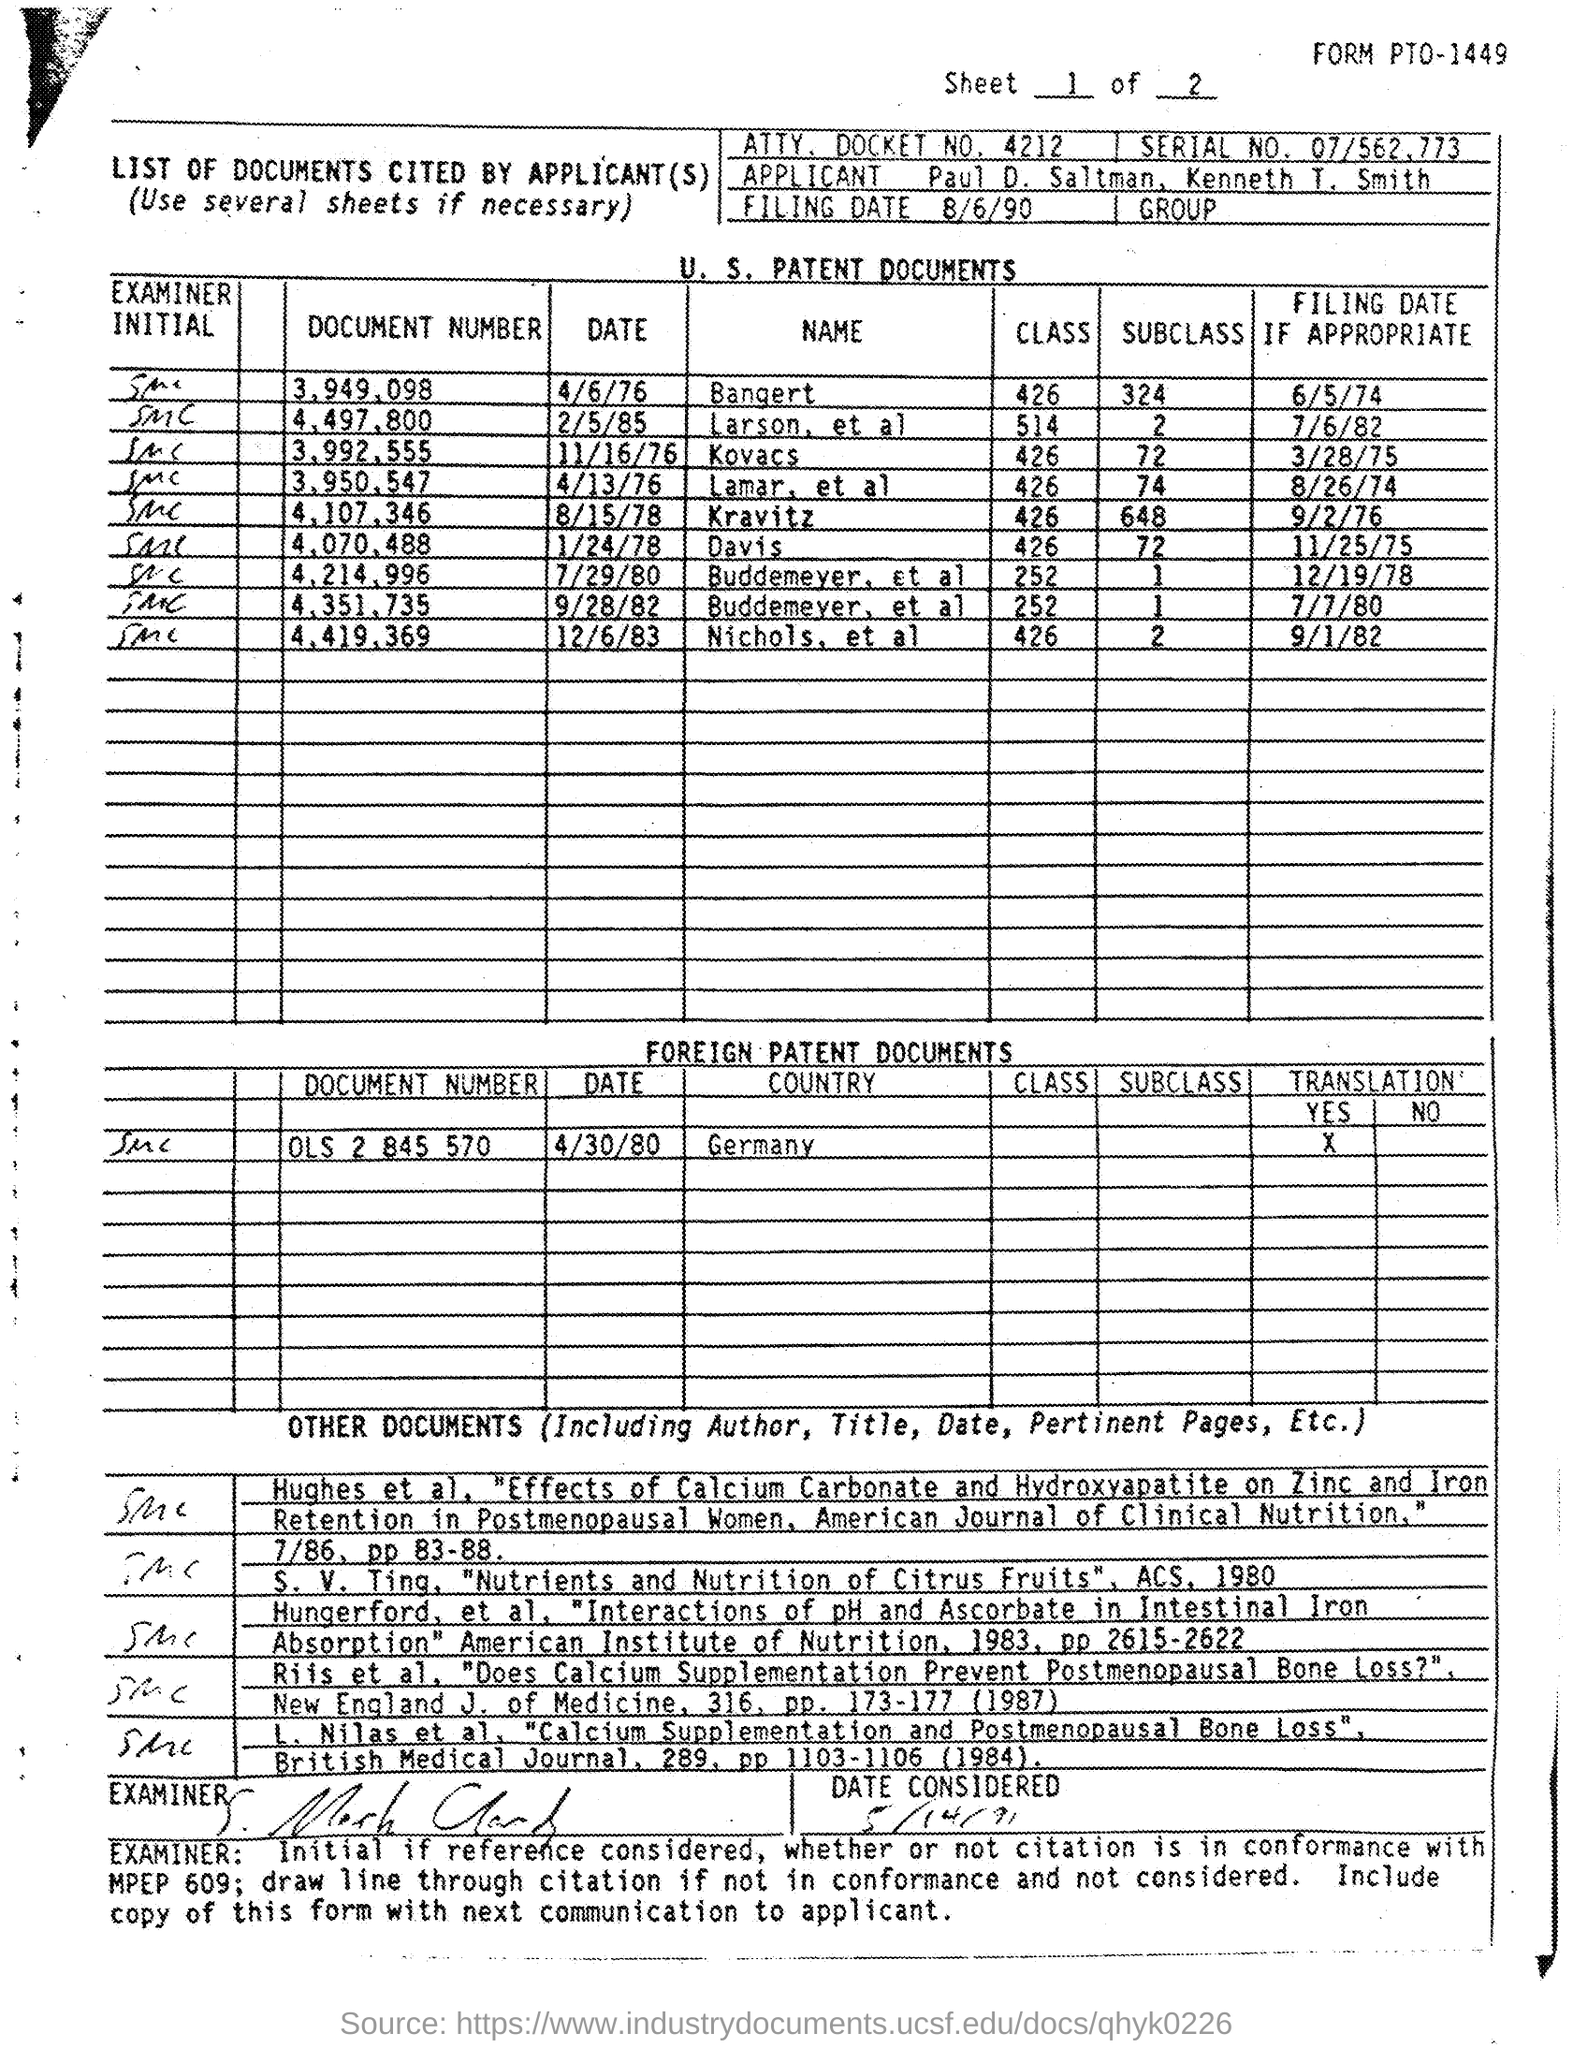What is the date for document number 3.949.098?
Provide a short and direct response. 4/6/76. Which is the country of the document number OLS 2 845 570?
Keep it short and to the point. Germany. 